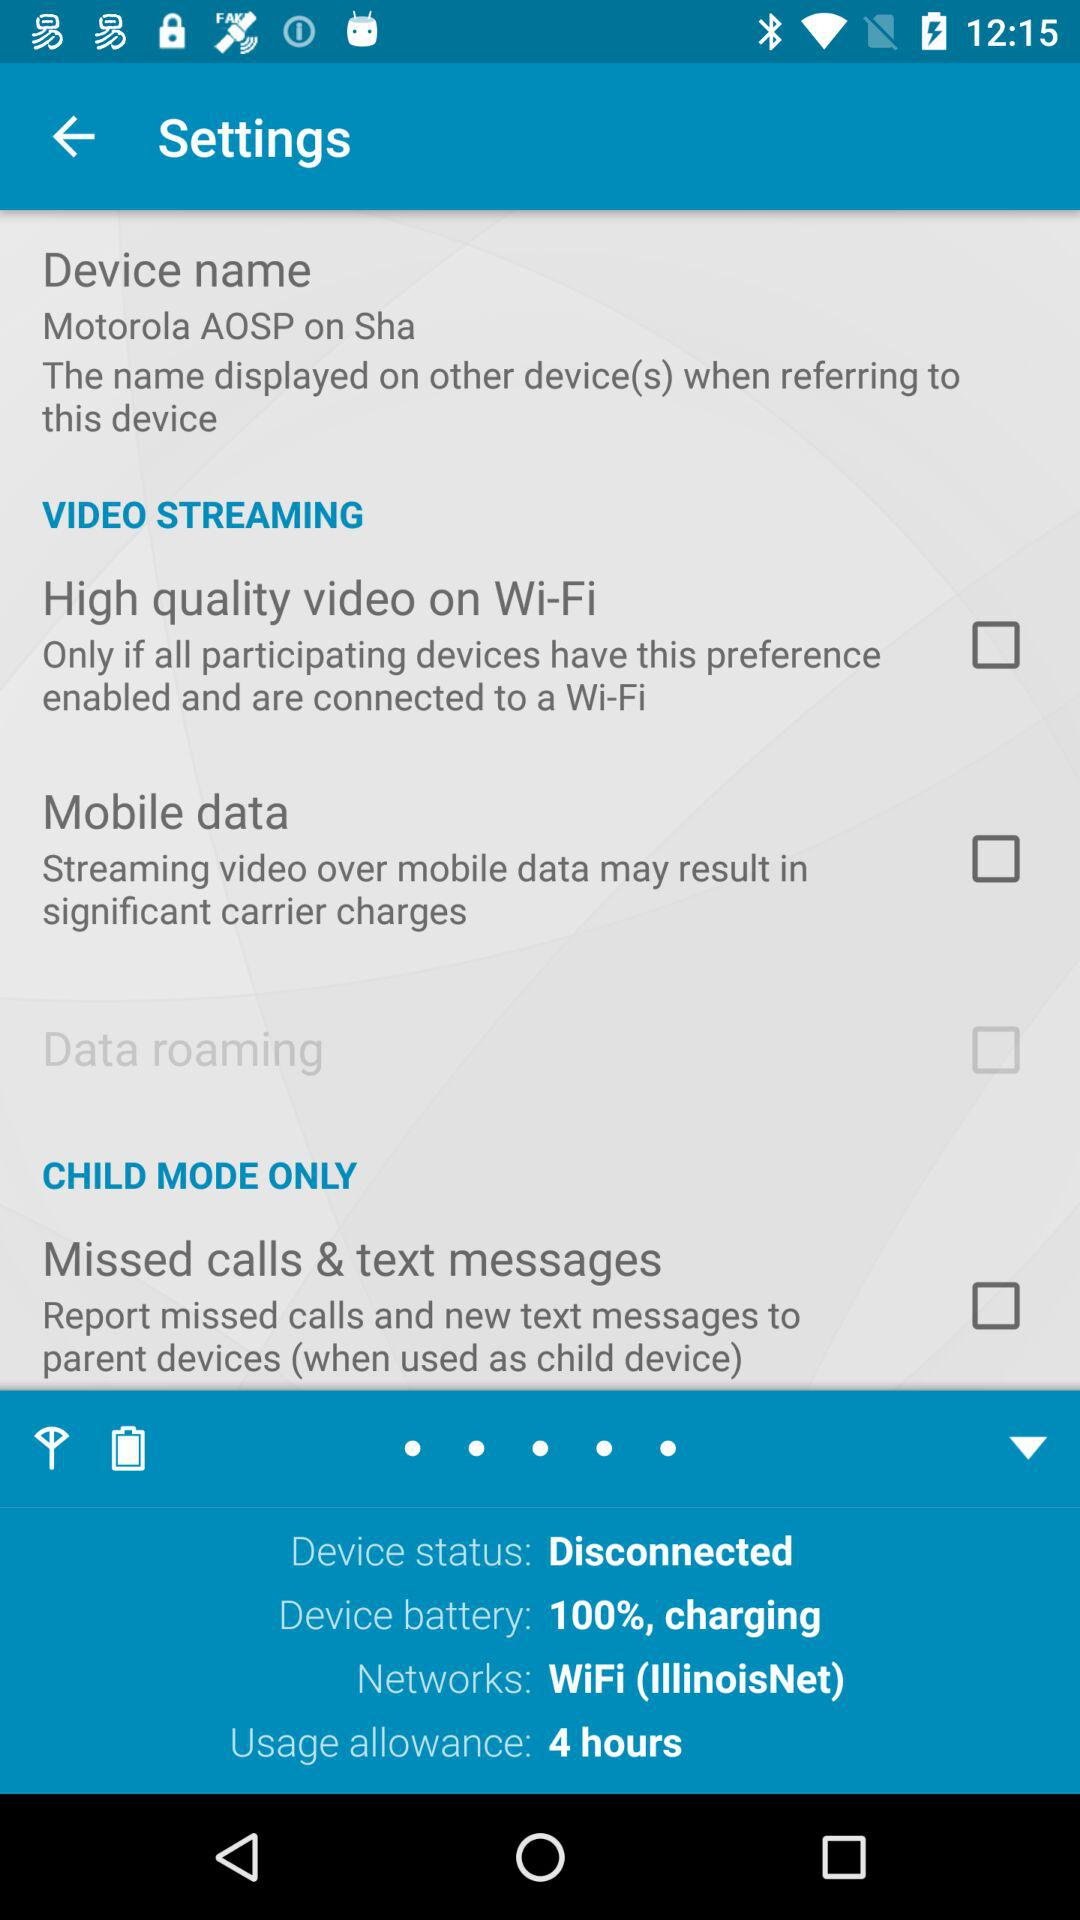What is the name of WiFi? The name of the WiFi is "IllinoisNet". 